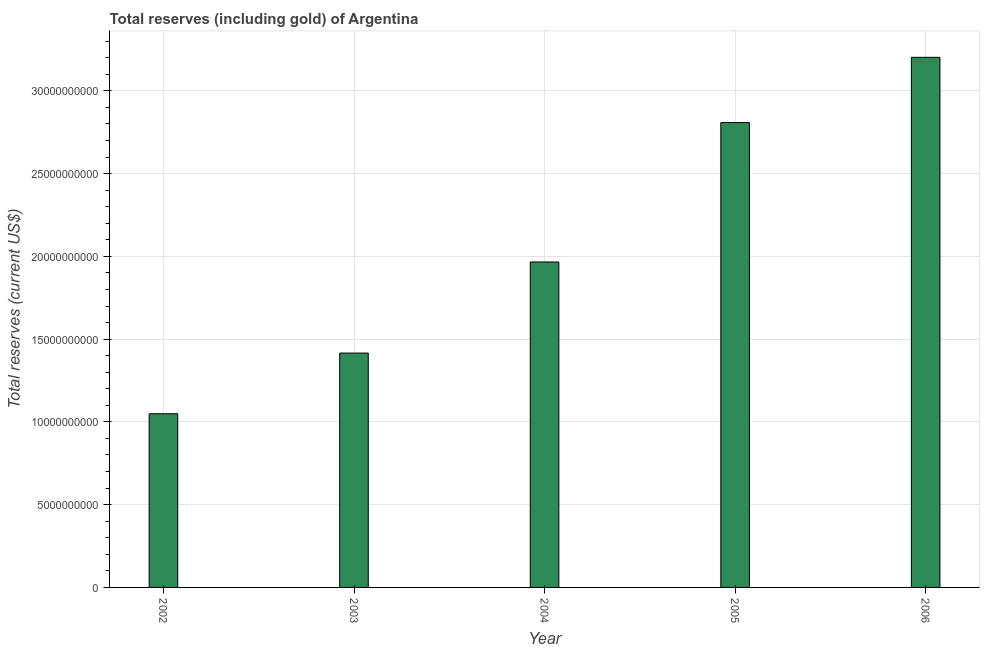Does the graph contain any zero values?
Make the answer very short. No. Does the graph contain grids?
Offer a terse response. Yes. What is the title of the graph?
Offer a very short reply. Total reserves (including gold) of Argentina. What is the label or title of the Y-axis?
Ensure brevity in your answer.  Total reserves (current US$). What is the total reserves (including gold) in 2003?
Your answer should be very brief. 1.42e+1. Across all years, what is the maximum total reserves (including gold)?
Your answer should be very brief. 3.20e+1. Across all years, what is the minimum total reserves (including gold)?
Your answer should be compact. 1.05e+1. In which year was the total reserves (including gold) maximum?
Offer a very short reply. 2006. In which year was the total reserves (including gold) minimum?
Make the answer very short. 2002. What is the sum of the total reserves (including gold)?
Provide a short and direct response. 1.04e+11. What is the difference between the total reserves (including gold) in 2002 and 2005?
Your answer should be compact. -1.76e+1. What is the average total reserves (including gold) per year?
Make the answer very short. 2.09e+1. What is the median total reserves (including gold)?
Provide a succinct answer. 1.97e+1. Do a majority of the years between 2003 and 2006 (inclusive) have total reserves (including gold) greater than 2000000000 US$?
Make the answer very short. Yes. What is the ratio of the total reserves (including gold) in 2005 to that in 2006?
Keep it short and to the point. 0.88. Is the total reserves (including gold) in 2004 less than that in 2005?
Offer a very short reply. Yes. What is the difference between the highest and the second highest total reserves (including gold)?
Provide a short and direct response. 3.94e+09. Is the sum of the total reserves (including gold) in 2003 and 2006 greater than the maximum total reserves (including gold) across all years?
Give a very brief answer. Yes. What is the difference between the highest and the lowest total reserves (including gold)?
Make the answer very short. 2.15e+1. How many bars are there?
Offer a very short reply. 5. Are all the bars in the graph horizontal?
Offer a very short reply. No. How many years are there in the graph?
Give a very brief answer. 5. What is the difference between two consecutive major ticks on the Y-axis?
Provide a short and direct response. 5.00e+09. What is the Total reserves (current US$) of 2002?
Provide a succinct answer. 1.05e+1. What is the Total reserves (current US$) in 2003?
Give a very brief answer. 1.42e+1. What is the Total reserves (current US$) in 2004?
Your answer should be very brief. 1.97e+1. What is the Total reserves (current US$) in 2005?
Keep it short and to the point. 2.81e+1. What is the Total reserves (current US$) of 2006?
Your answer should be very brief. 3.20e+1. What is the difference between the Total reserves (current US$) in 2002 and 2003?
Keep it short and to the point. -3.66e+09. What is the difference between the Total reserves (current US$) in 2002 and 2004?
Provide a succinct answer. -9.17e+09. What is the difference between the Total reserves (current US$) in 2002 and 2005?
Provide a short and direct response. -1.76e+1. What is the difference between the Total reserves (current US$) in 2002 and 2006?
Offer a very short reply. -2.15e+1. What is the difference between the Total reserves (current US$) in 2003 and 2004?
Your answer should be compact. -5.50e+09. What is the difference between the Total reserves (current US$) in 2003 and 2005?
Your answer should be compact. -1.39e+1. What is the difference between the Total reserves (current US$) in 2003 and 2006?
Your answer should be compact. -1.79e+1. What is the difference between the Total reserves (current US$) in 2004 and 2005?
Ensure brevity in your answer.  -8.42e+09. What is the difference between the Total reserves (current US$) in 2004 and 2006?
Offer a very short reply. -1.24e+1. What is the difference between the Total reserves (current US$) in 2005 and 2006?
Keep it short and to the point. -3.94e+09. What is the ratio of the Total reserves (current US$) in 2002 to that in 2003?
Keep it short and to the point. 0.74. What is the ratio of the Total reserves (current US$) in 2002 to that in 2004?
Keep it short and to the point. 0.53. What is the ratio of the Total reserves (current US$) in 2002 to that in 2005?
Ensure brevity in your answer.  0.37. What is the ratio of the Total reserves (current US$) in 2002 to that in 2006?
Give a very brief answer. 0.33. What is the ratio of the Total reserves (current US$) in 2003 to that in 2004?
Provide a short and direct response. 0.72. What is the ratio of the Total reserves (current US$) in 2003 to that in 2005?
Give a very brief answer. 0.5. What is the ratio of the Total reserves (current US$) in 2003 to that in 2006?
Ensure brevity in your answer.  0.44. What is the ratio of the Total reserves (current US$) in 2004 to that in 2006?
Ensure brevity in your answer.  0.61. What is the ratio of the Total reserves (current US$) in 2005 to that in 2006?
Your answer should be very brief. 0.88. 